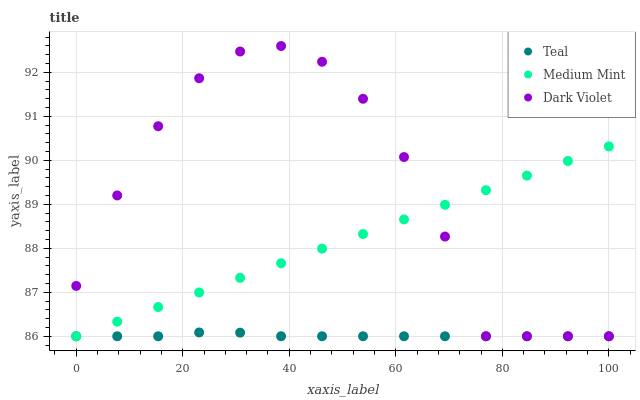Does Teal have the minimum area under the curve?
Answer yes or no. Yes. Does Dark Violet have the maximum area under the curve?
Answer yes or no. Yes. Does Dark Violet have the minimum area under the curve?
Answer yes or no. No. Does Teal have the maximum area under the curve?
Answer yes or no. No. Is Medium Mint the smoothest?
Answer yes or no. Yes. Is Dark Violet the roughest?
Answer yes or no. Yes. Is Teal the smoothest?
Answer yes or no. No. Is Teal the roughest?
Answer yes or no. No. Does Medium Mint have the lowest value?
Answer yes or no. Yes. Does Dark Violet have the highest value?
Answer yes or no. Yes. Does Teal have the highest value?
Answer yes or no. No. Does Medium Mint intersect Dark Violet?
Answer yes or no. Yes. Is Medium Mint less than Dark Violet?
Answer yes or no. No. Is Medium Mint greater than Dark Violet?
Answer yes or no. No. 